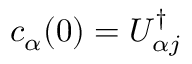Convert formula to latex. <formula><loc_0><loc_0><loc_500><loc_500>c _ { \alpha } ( 0 ) = U _ { \alpha j } ^ { \dagger }</formula> 